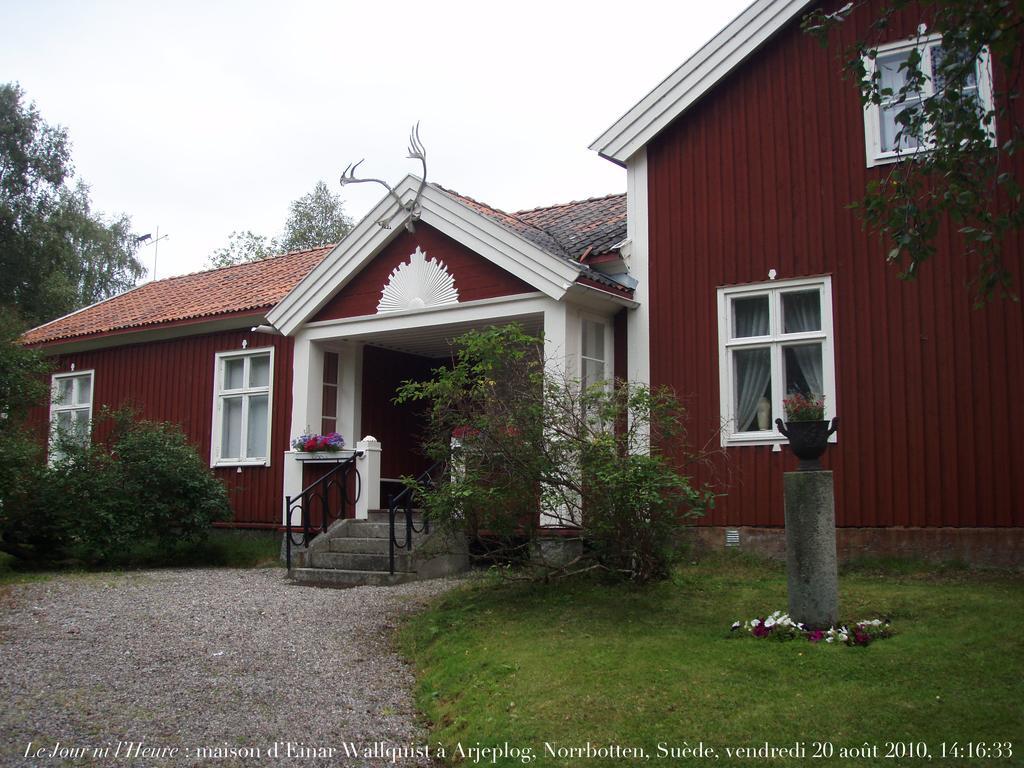In one or two sentences, can you explain what this image depicts? In this image we can see the house with stairs, flowers, plants and also trees. At the top there is sky and at the bottom we can see the ground, grass and also the text. We can also see the flower pot on small pillar. 